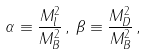<formula> <loc_0><loc_0><loc_500><loc_500>\alpha \equiv \frac { M ^ { 2 } _ { l } } { M ^ { 2 } _ { B } } \, , \, \beta \equiv \frac { M ^ { 2 } _ { D } } { M ^ { 2 } _ { B } } \, ,</formula> 